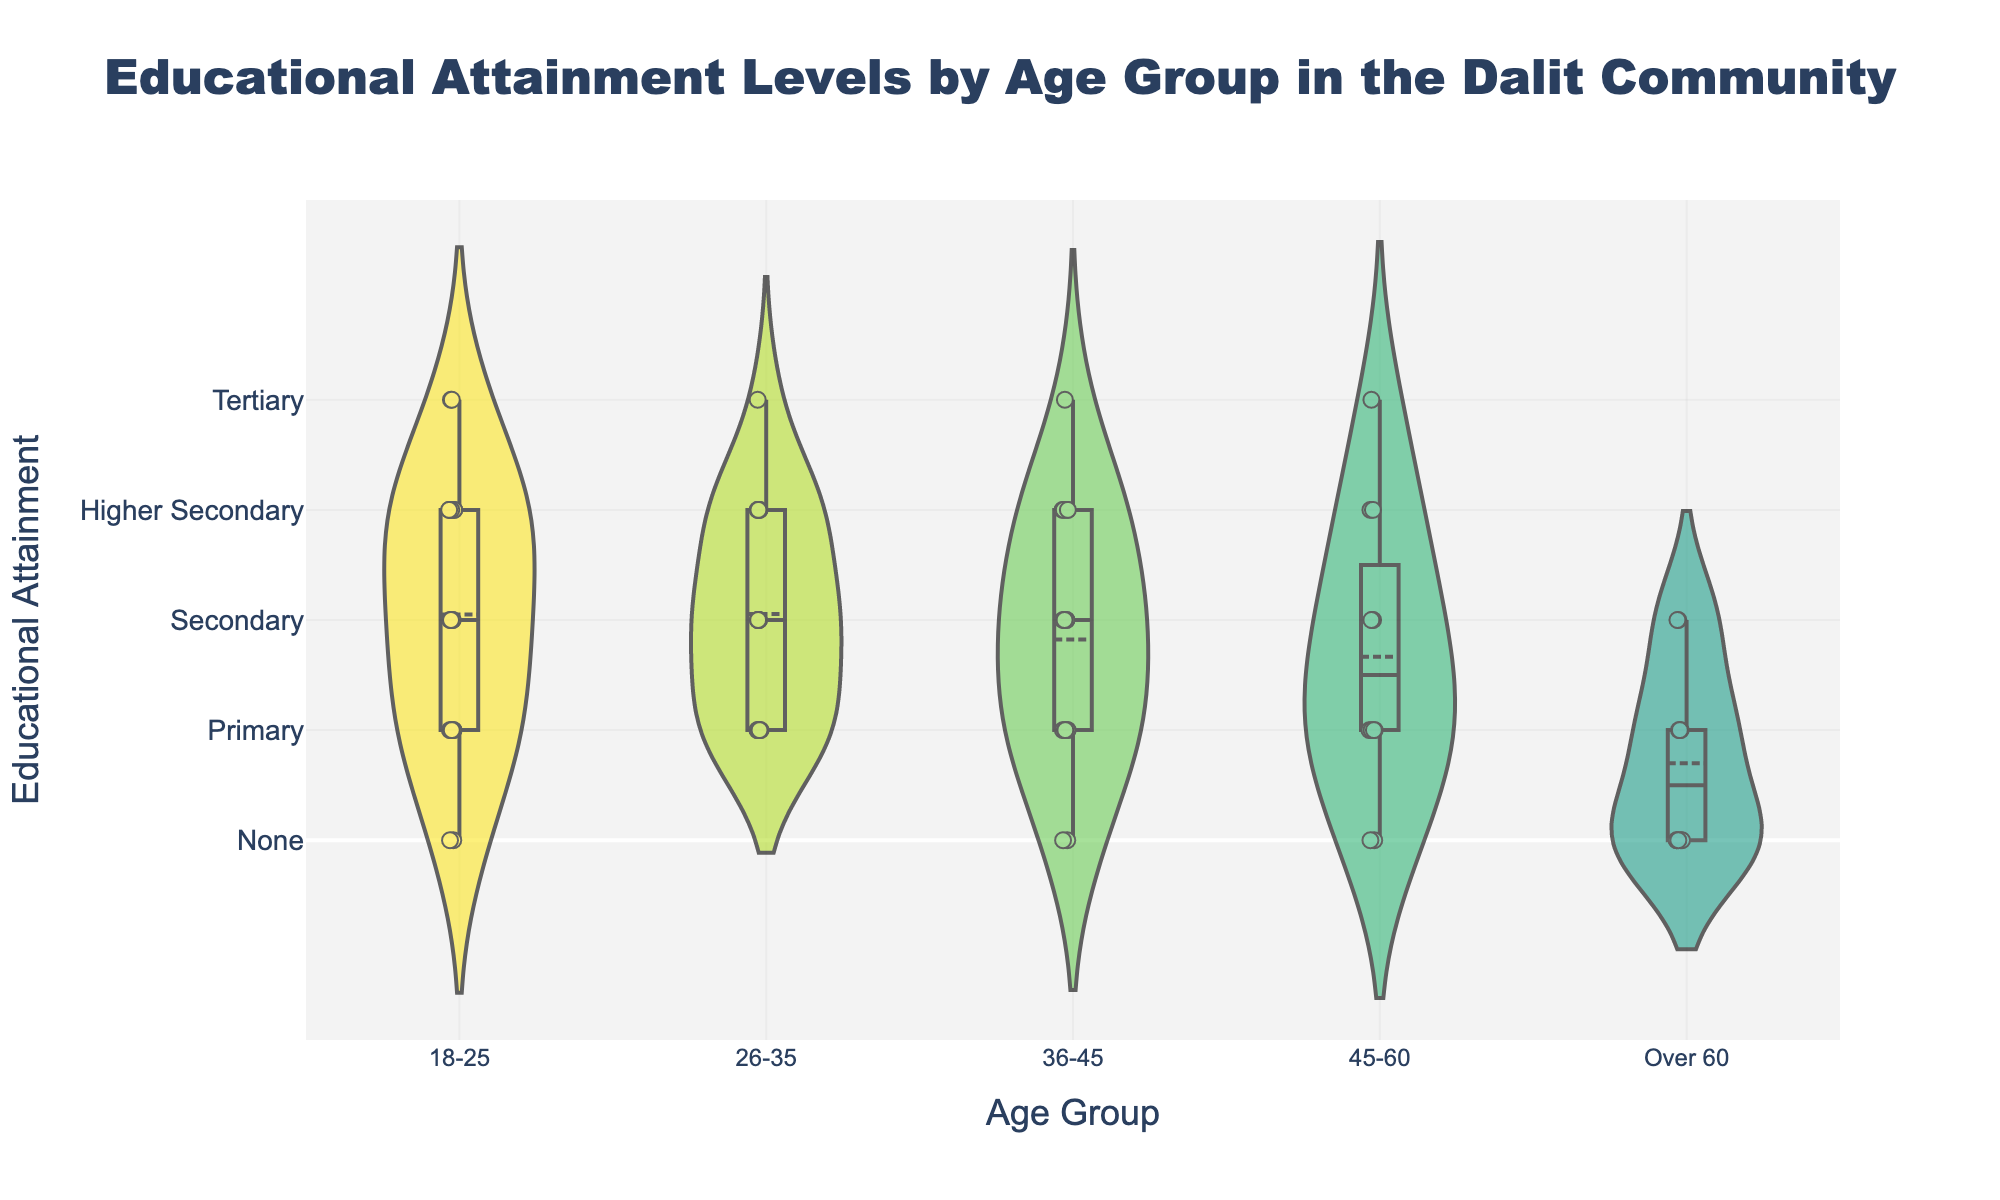What is the title of the figure? The title is usually found at the top of the figure, often in a visually distinct font and size to make it stand out. In this case, the title is "Educational Attainment Levels by Age Group in the Dalit Community".
Answer: Educational Attainment Levels by Age Group in the Dalit Community What are the Y-axis labels representing? The Y-axis contains labels that provide information about the data being measured. Here, the Y-axis labels indicate different levels of educational attainment: None, Primary, Secondary, HigherSecondary, and Tertiary.
Answer: Educational Attainment What's the highest educational attainment level for the age group 18-25? To find the highest educational attainment, look at the Y-axis values of the jittered points for this age group. The highest Y-value is 4, indicating Tertiary education.
Answer: Tertiary Which age group has the most diverse (widest spread) educational attainment levels? This can be observed by checking the range of the jittered points along the Y-axis for each age group. The age group 18-25 has data points scattered from None (0) to Tertiary (4), showing the widest spread.
Answer: 18-25 How does the educational attainment of age group over 60 compare with 26-35? Compare the range and central tendency of jittered points for both age groups. The over 60 group has mostly None and Primary levels (0 and 1), while the 26-35 group spans from Primary (1) to Tertiary (4), indicating higher educational diversity.
Answer: Over 60 has lower educational attainment Which age group has a clear cluster at the Secondary level? Look for groups with a high concentration of jittered points at the Y-value representing Secondary (2). The age group 26-35 shows a dense cluster around this value.
Answer: 26-35 What is the box plot element shown within the violin plots, and what information does it give? The box plot element includes a box and a line. The box represents the interquartile range where the middle 50% of values lie, and the line represents the median. It gives a quick visualization of data spread and central tendency within each age group.
Answer: Interquartile range and median Do any age groups lack representation in HigherSecondary educational attainment? Scan the Y-axis value corresponding to HigherSecondary (3) for all age groups. The over 60 age group does not have any points at this educational level.
Answer: Over 60 Which age group has the highest number of individuals with no education (None)? Count the points at the Y-value corresponding to None (0) for all age groups. The over 60 age group has the highest number of points at this level.
Answer: Over 60 